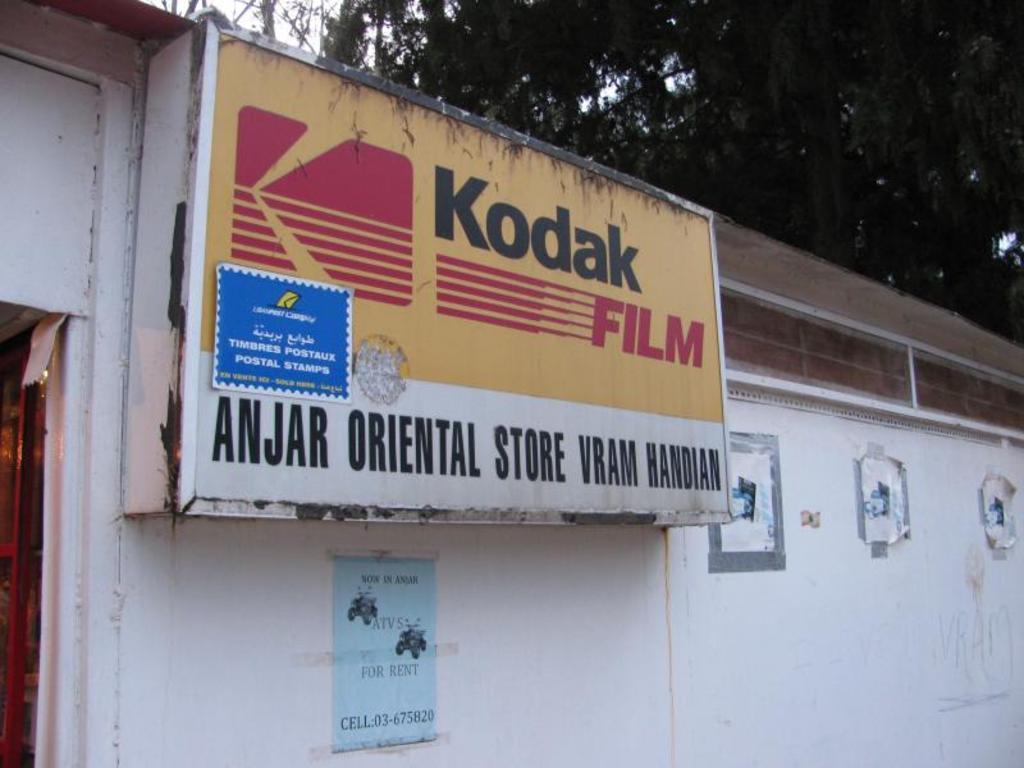In one or two sentences, can you explain what this image depicts? In this image there is a building with a name board , there are papers stick to the wall of the building, and in the background there are trees,sky. 